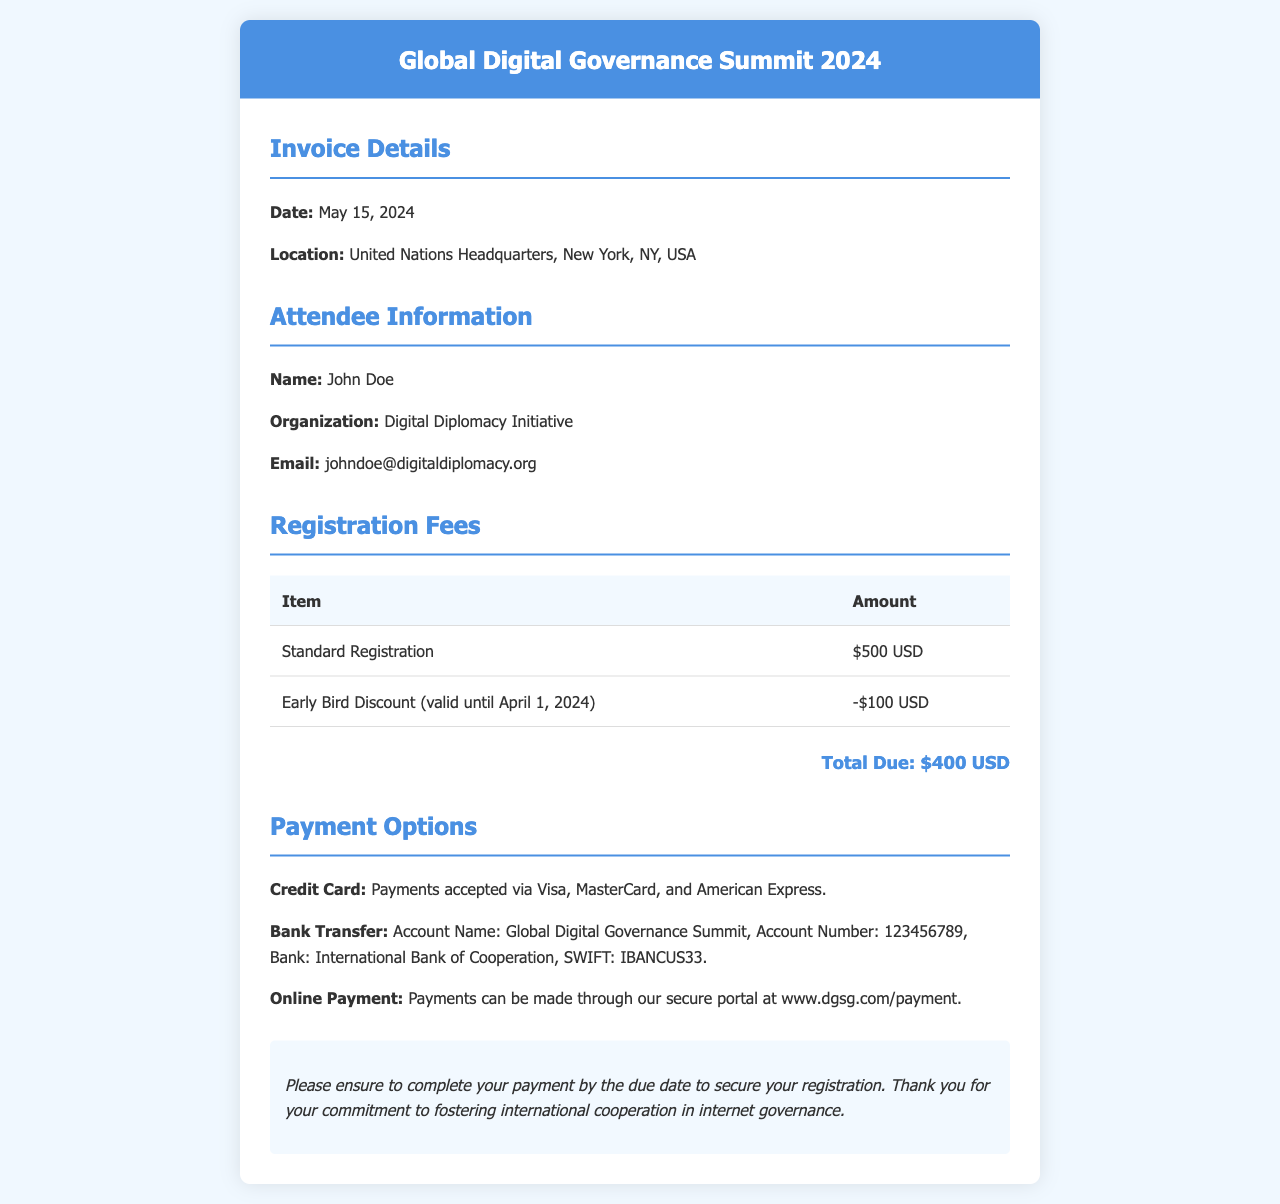What is the total due amount? The total due amount is found in the fee details section, calculated after applying the early bird discount to the standard registration fee.
Answer: $400 USD What is the date of the invoice? The date of the invoice is specified in the invoice details section.
Answer: May 15, 2024 What is the name of the attendee? The name of the attendee is mentioned in the attendee information section of the document.
Answer: John Doe Which organization is the attendee associated with? The organization of the attendee is noted in the attendee details section.
Answer: Digital Diplomacy Initiative What discount is applied for early registration? The discount amount is listed in the fee details section, indicating the reduction for early bird registration.
Answer: -$100 USD Where is the conference located? The location of the conference is detailed in the invoice details section.
Answer: United Nations Headquarters, New York, NY, USA What payment method accepts Visa? The payment options section mentions various methods of payment, including credit cards.
Answer: Credit Card When is the early bird discount valid until? The early bird discount's validity is stated in the fee details section of the document.
Answer: April 1, 2024 What is the account name for bank transfers? The account name for bank transfers is specified in the payment options section.
Answer: Global Digital Governance Summit 